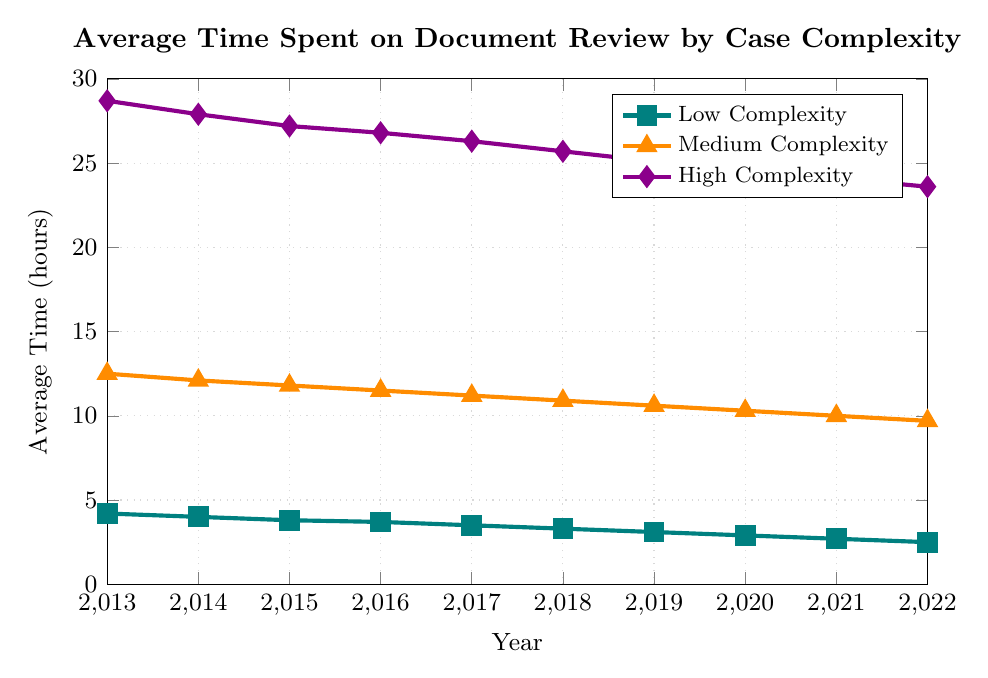Which complexity level saw the greatest decrease in average time spent on document review from 2013 to 2022? The figure shows that High Complexity, Medium Complexity, and Low Complexity cases all saw decreases. By looking at the y-axis values for 2013 and 2022: Low Complexity decreased from 4.2 to 2.5 (a decrease of 1.7), Medium Complexity from 12.5 to 9.7 (a decrease of 2.8), and High Complexity from 28.7 to 23.6 (a decrease of 5.1). High Complexity had the greatest decrease.
Answer: High Complexity By how many hours did the average time spent on document review for Medium Complexity cases decrease between 2013 and 2022? From the y-axis, in 2013, the average time was 12.5 hours, and in 2022, it was 9.7 hours. The difference is calculated as 12.5 - 9.7 = 2.8 hours.
Answer: 2.8 hours Which year displayed the smallest difference in average time spent on document review between Low Complexity and Medium Complexity cases? We need to compare the differences each year. For example, in 2013: 12.5 (Medium) - 4.2 (Low) = 8.3, and similar calculations for other years. The smallest difference is obtained in 2022: 9.7 - 2.5 = 7.2.
Answer: 2022 What trend is visible in the average time spent on document review for Low Complexity cases over the years? Observing the line plot for Low Complexity (marked with squares and colored differently), it shows a continuous decrease from 4.2 hours in 2013 to 2.5 hours in 2022.
Answer: Continuous decrease How does the average time spent on document review in 2022 for High Complexity cases compare to Low Complexity cases in 2013? In 2022, the average time for High Complexity was 23.6 hours. For Low Complexity in 2013, it was 4.2 hours. To compare: 23.6 - 4.2 = 19.4 hours. High Complexity cases in 2022 took 19.4 hours more on average.
Answer: High Complexity in 2022 took 19.4 hours more 